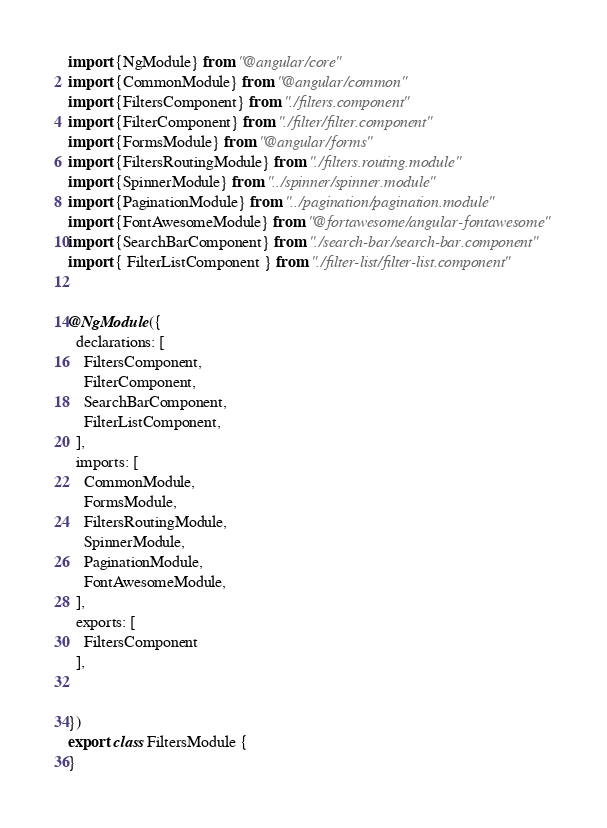<code> <loc_0><loc_0><loc_500><loc_500><_TypeScript_>import {NgModule} from "@angular/core"
import {CommonModule} from "@angular/common"
import {FiltersComponent} from "./filters.component"
import {FilterComponent} from "./filter/filter.component"
import {FormsModule} from "@angular/forms"
import {FiltersRoutingModule} from "./filters.routing.module"
import {SpinnerModule} from "../spinner/spinner.module"
import {PaginationModule} from "../pagination/pagination.module"
import {FontAwesomeModule} from "@fortawesome/angular-fontawesome"
import {SearchBarComponent} from "./search-bar/search-bar.component"
import { FilterListComponent } from "./filter-list/filter-list.component"


@NgModule({
  declarations: [
    FiltersComponent,
    FilterComponent,
    SearchBarComponent,
    FilterListComponent,
  ],
  imports: [
    CommonModule,
    FormsModule,
    FiltersRoutingModule,
    SpinnerModule,
    PaginationModule,
    FontAwesomeModule,
  ],
  exports: [
    FiltersComponent
  ],


})
export class FiltersModule {
}
</code> 